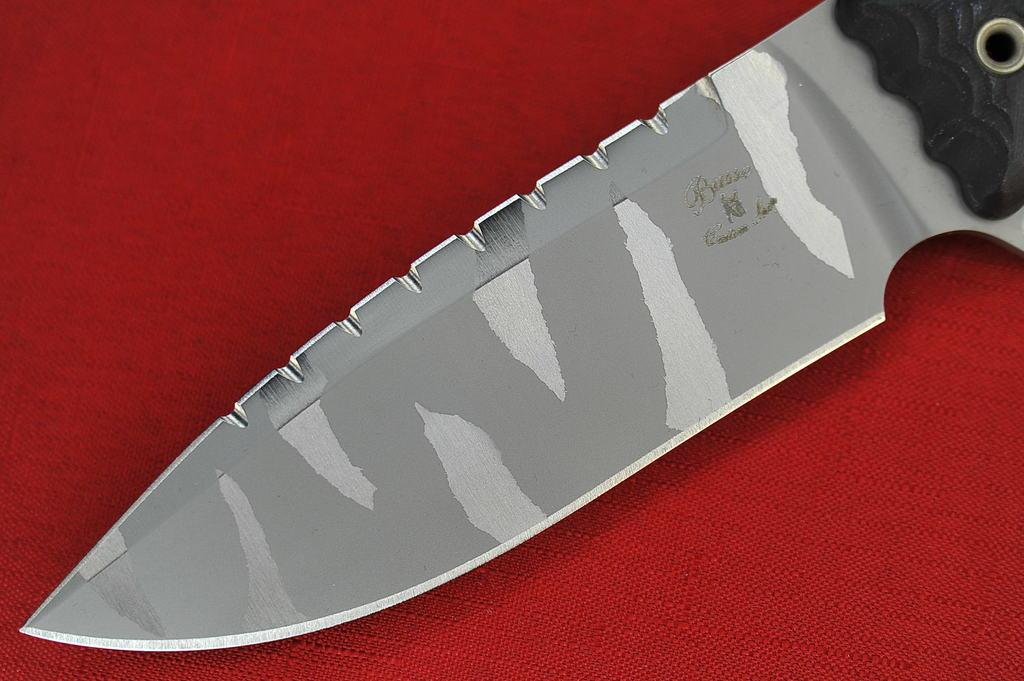What color is the surface in the image? The surface in the image is red. What object is placed on the red surface? There is a knife on the red surface. Can you describe the appearance of the knife? The knife is silver and black in color. What is the manager doing with their head and leg in the image? There is no manager, head, or leg present in the image. 